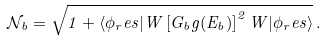<formula> <loc_0><loc_0><loc_500><loc_500>\mathcal { N } _ { b } = \sqrt { 1 + \langle \phi _ { r } e s | W \left [ G _ { b } g ( E _ { b } ) \right ] ^ { 2 } W | \phi _ { r } e s \rangle } \, .</formula> 